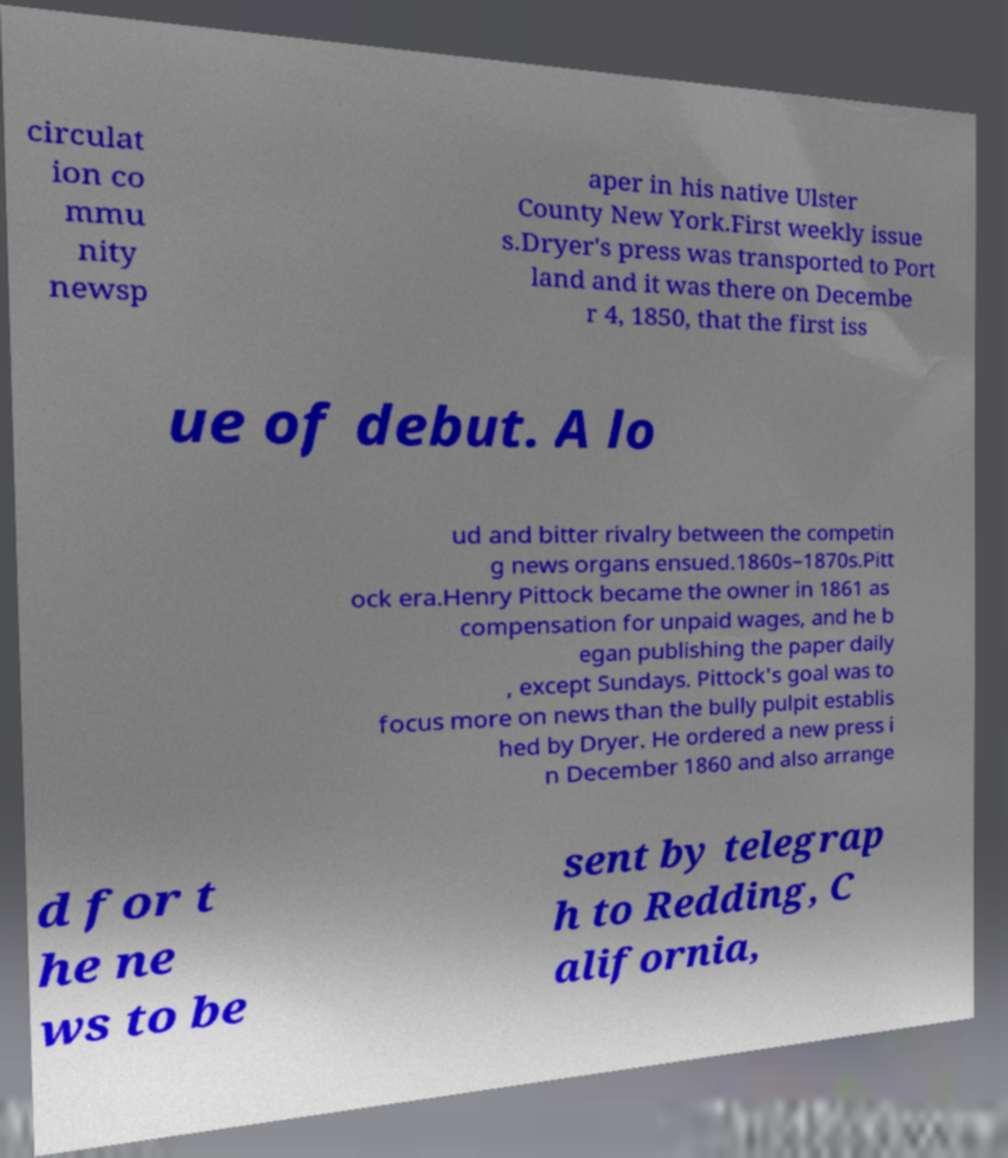I need the written content from this picture converted into text. Can you do that? circulat ion co mmu nity newsp aper in his native Ulster County New York.First weekly issue s.Dryer's press was transported to Port land and it was there on Decembe r 4, 1850, that the first iss ue of debut. A lo ud and bitter rivalry between the competin g news organs ensued.1860s–1870s.Pitt ock era.Henry Pittock became the owner in 1861 as compensation for unpaid wages, and he b egan publishing the paper daily , except Sundays. Pittock's goal was to focus more on news than the bully pulpit establis hed by Dryer. He ordered a new press i n December 1860 and also arrange d for t he ne ws to be sent by telegrap h to Redding, C alifornia, 